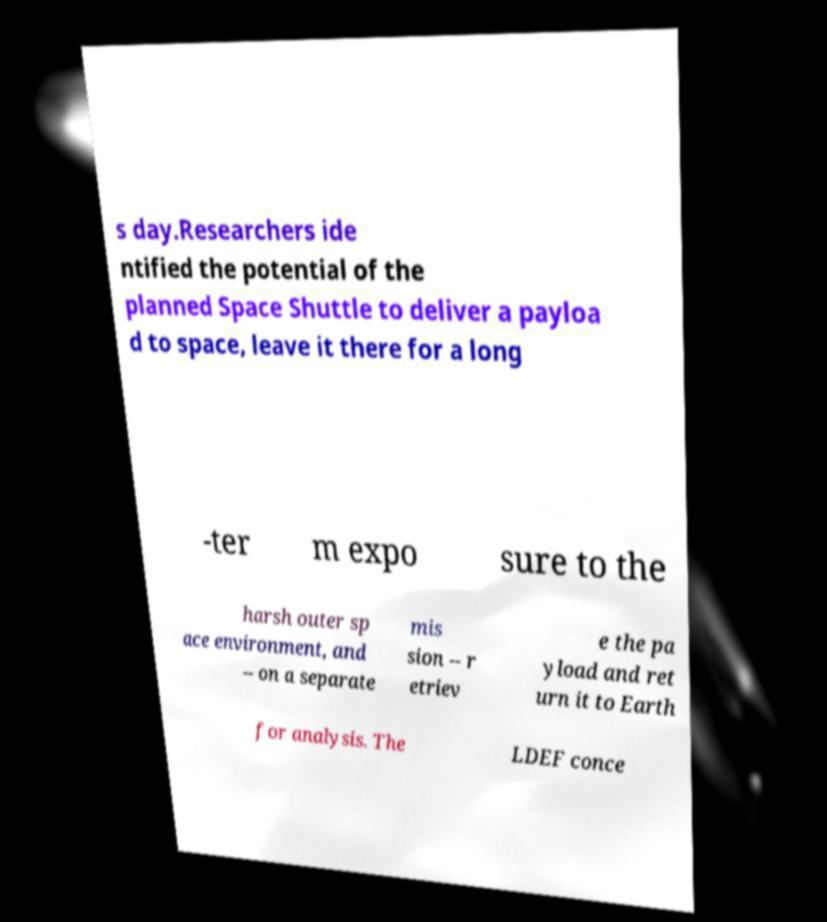For documentation purposes, I need the text within this image transcribed. Could you provide that? s day.Researchers ide ntified the potential of the planned Space Shuttle to deliver a payloa d to space, leave it there for a long -ter m expo sure to the harsh outer sp ace environment, and -- on a separate mis sion -- r etriev e the pa yload and ret urn it to Earth for analysis. The LDEF conce 